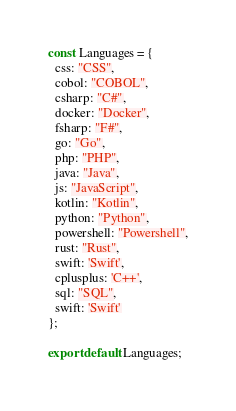Convert code to text. <code><loc_0><loc_0><loc_500><loc_500><_JavaScript_>const Languages = {
  css: "CSS",
  cobol: "COBOL",
  csharp: "C#",
  docker: "Docker",
  fsharp: "F#",
  go: "Go",
  php: "PHP",
  java: "Java",
  js: "JavaScript",
  kotlin: "Kotlin",
  python: "Python",
  powershell: "Powershell",
  rust: "Rust",
  swift: 'Swift',
  cplusplus: 'C++',
  sql: "SQL",
  swift: 'Swift'
};

export default Languages;
</code> 